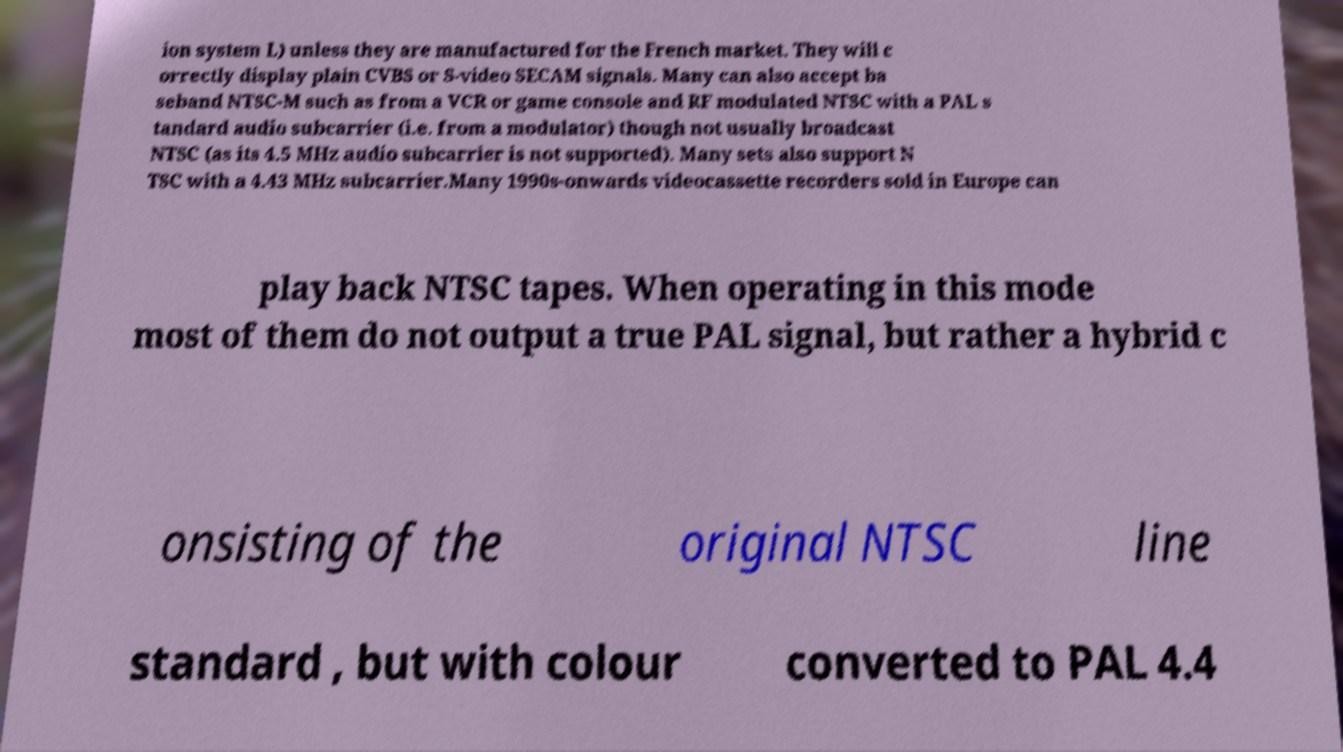Could you extract and type out the text from this image? ion system L) unless they are manufactured for the French market. They will c orrectly display plain CVBS or S-video SECAM signals. Many can also accept ba seband NTSC-M such as from a VCR or game console and RF modulated NTSC with a PAL s tandard audio subcarrier (i.e. from a modulator) though not usually broadcast NTSC (as its 4.5 MHz audio subcarrier is not supported). Many sets also support N TSC with a 4.43 MHz subcarrier.Many 1990s-onwards videocassette recorders sold in Europe can play back NTSC tapes. When operating in this mode most of them do not output a true PAL signal, but rather a hybrid c onsisting of the original NTSC line standard , but with colour converted to PAL 4.4 